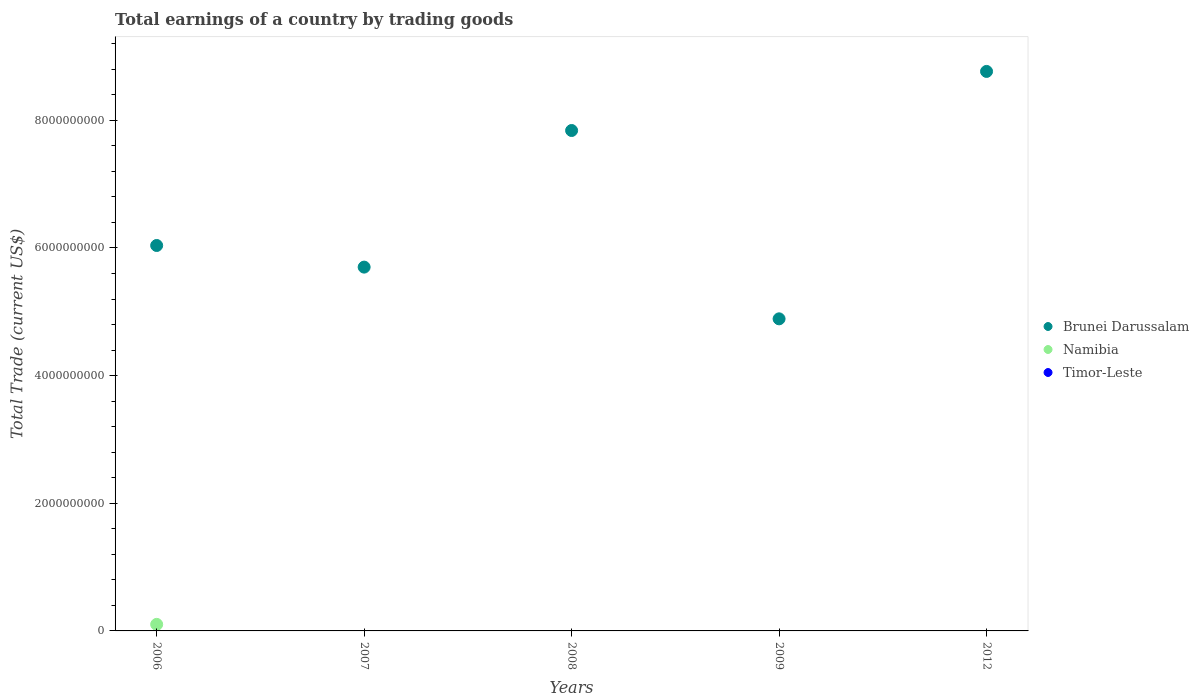What is the total earnings in Timor-Leste in 2009?
Offer a terse response. 0. Across all years, what is the maximum total earnings in Namibia?
Keep it short and to the point. 1.02e+08. Across all years, what is the minimum total earnings in Timor-Leste?
Keep it short and to the point. 0. In which year was the total earnings in Namibia maximum?
Make the answer very short. 2006. What is the total total earnings in Brunei Darussalam in the graph?
Keep it short and to the point. 3.32e+1. What is the difference between the total earnings in Brunei Darussalam in 2007 and that in 2009?
Give a very brief answer. 8.10e+08. What is the difference between the total earnings in Namibia in 2009 and the total earnings in Timor-Leste in 2008?
Provide a succinct answer. 0. What is the average total earnings in Brunei Darussalam per year?
Offer a terse response. 6.65e+09. In the year 2006, what is the difference between the total earnings in Brunei Darussalam and total earnings in Namibia?
Make the answer very short. 5.94e+09. What is the ratio of the total earnings in Brunei Darussalam in 2007 to that in 2009?
Offer a very short reply. 1.17. What is the difference between the highest and the second highest total earnings in Brunei Darussalam?
Provide a short and direct response. 9.26e+08. What is the difference between the highest and the lowest total earnings in Namibia?
Provide a short and direct response. 1.02e+08. In how many years, is the total earnings in Timor-Leste greater than the average total earnings in Timor-Leste taken over all years?
Your answer should be compact. 0. Is it the case that in every year, the sum of the total earnings in Namibia and total earnings in Brunei Darussalam  is greater than the total earnings in Timor-Leste?
Offer a very short reply. Yes. Is the total earnings in Timor-Leste strictly less than the total earnings in Brunei Darussalam over the years?
Offer a very short reply. Yes. Does the graph contain grids?
Provide a succinct answer. No. Where does the legend appear in the graph?
Offer a very short reply. Center right. How are the legend labels stacked?
Your answer should be compact. Vertical. What is the title of the graph?
Provide a succinct answer. Total earnings of a country by trading goods. What is the label or title of the X-axis?
Ensure brevity in your answer.  Years. What is the label or title of the Y-axis?
Your response must be concise. Total Trade (current US$). What is the Total Trade (current US$) in Brunei Darussalam in 2006?
Keep it short and to the point. 6.04e+09. What is the Total Trade (current US$) of Namibia in 2006?
Offer a terse response. 1.02e+08. What is the Total Trade (current US$) of Timor-Leste in 2006?
Offer a very short reply. 0. What is the Total Trade (current US$) of Brunei Darussalam in 2007?
Make the answer very short. 5.70e+09. What is the Total Trade (current US$) of Brunei Darussalam in 2008?
Provide a short and direct response. 7.84e+09. What is the Total Trade (current US$) of Namibia in 2008?
Offer a terse response. 0. What is the Total Trade (current US$) in Timor-Leste in 2008?
Offer a terse response. 0. What is the Total Trade (current US$) in Brunei Darussalam in 2009?
Your response must be concise. 4.89e+09. What is the Total Trade (current US$) in Namibia in 2009?
Provide a short and direct response. 0. What is the Total Trade (current US$) of Timor-Leste in 2009?
Ensure brevity in your answer.  0. What is the Total Trade (current US$) of Brunei Darussalam in 2012?
Your answer should be very brief. 8.77e+09. What is the Total Trade (current US$) in Timor-Leste in 2012?
Your answer should be very brief. 0. Across all years, what is the maximum Total Trade (current US$) of Brunei Darussalam?
Provide a succinct answer. 8.77e+09. Across all years, what is the maximum Total Trade (current US$) of Namibia?
Your response must be concise. 1.02e+08. Across all years, what is the minimum Total Trade (current US$) of Brunei Darussalam?
Offer a very short reply. 4.89e+09. What is the total Total Trade (current US$) in Brunei Darussalam in the graph?
Your answer should be very brief. 3.32e+1. What is the total Total Trade (current US$) of Namibia in the graph?
Keep it short and to the point. 1.02e+08. What is the total Total Trade (current US$) of Timor-Leste in the graph?
Provide a succinct answer. 0. What is the difference between the Total Trade (current US$) of Brunei Darussalam in 2006 and that in 2007?
Your answer should be compact. 3.39e+08. What is the difference between the Total Trade (current US$) of Brunei Darussalam in 2006 and that in 2008?
Offer a terse response. -1.80e+09. What is the difference between the Total Trade (current US$) in Brunei Darussalam in 2006 and that in 2009?
Make the answer very short. 1.15e+09. What is the difference between the Total Trade (current US$) in Brunei Darussalam in 2006 and that in 2012?
Offer a very short reply. -2.73e+09. What is the difference between the Total Trade (current US$) of Brunei Darussalam in 2007 and that in 2008?
Your response must be concise. -2.14e+09. What is the difference between the Total Trade (current US$) in Brunei Darussalam in 2007 and that in 2009?
Provide a short and direct response. 8.10e+08. What is the difference between the Total Trade (current US$) of Brunei Darussalam in 2007 and that in 2012?
Your answer should be very brief. -3.07e+09. What is the difference between the Total Trade (current US$) of Brunei Darussalam in 2008 and that in 2009?
Provide a succinct answer. 2.95e+09. What is the difference between the Total Trade (current US$) of Brunei Darussalam in 2008 and that in 2012?
Your response must be concise. -9.26e+08. What is the difference between the Total Trade (current US$) in Brunei Darussalam in 2009 and that in 2012?
Give a very brief answer. -3.88e+09. What is the average Total Trade (current US$) in Brunei Darussalam per year?
Ensure brevity in your answer.  6.65e+09. What is the average Total Trade (current US$) in Namibia per year?
Provide a short and direct response. 2.05e+07. In the year 2006, what is the difference between the Total Trade (current US$) of Brunei Darussalam and Total Trade (current US$) of Namibia?
Your response must be concise. 5.94e+09. What is the ratio of the Total Trade (current US$) of Brunei Darussalam in 2006 to that in 2007?
Offer a very short reply. 1.06. What is the ratio of the Total Trade (current US$) in Brunei Darussalam in 2006 to that in 2008?
Your response must be concise. 0.77. What is the ratio of the Total Trade (current US$) in Brunei Darussalam in 2006 to that in 2009?
Give a very brief answer. 1.24. What is the ratio of the Total Trade (current US$) in Brunei Darussalam in 2006 to that in 2012?
Offer a very short reply. 0.69. What is the ratio of the Total Trade (current US$) in Brunei Darussalam in 2007 to that in 2008?
Give a very brief answer. 0.73. What is the ratio of the Total Trade (current US$) of Brunei Darussalam in 2007 to that in 2009?
Your answer should be compact. 1.17. What is the ratio of the Total Trade (current US$) of Brunei Darussalam in 2007 to that in 2012?
Provide a succinct answer. 0.65. What is the ratio of the Total Trade (current US$) in Brunei Darussalam in 2008 to that in 2009?
Provide a succinct answer. 1.6. What is the ratio of the Total Trade (current US$) of Brunei Darussalam in 2008 to that in 2012?
Offer a terse response. 0.89. What is the ratio of the Total Trade (current US$) of Brunei Darussalam in 2009 to that in 2012?
Provide a succinct answer. 0.56. What is the difference between the highest and the second highest Total Trade (current US$) of Brunei Darussalam?
Offer a very short reply. 9.26e+08. What is the difference between the highest and the lowest Total Trade (current US$) in Brunei Darussalam?
Provide a succinct answer. 3.88e+09. What is the difference between the highest and the lowest Total Trade (current US$) in Namibia?
Provide a short and direct response. 1.02e+08. 